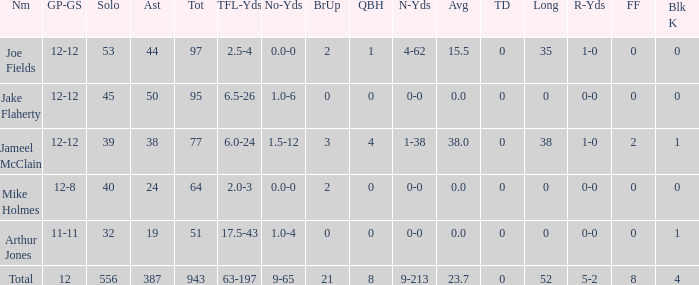How many players named jake flaherty? 1.0. 